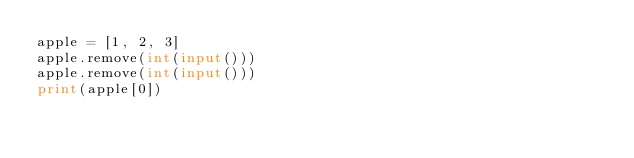<code> <loc_0><loc_0><loc_500><loc_500><_Python_>apple = [1, 2, 3]
apple.remove(int(input()))
apple.remove(int(input()))
print(apple[0])</code> 